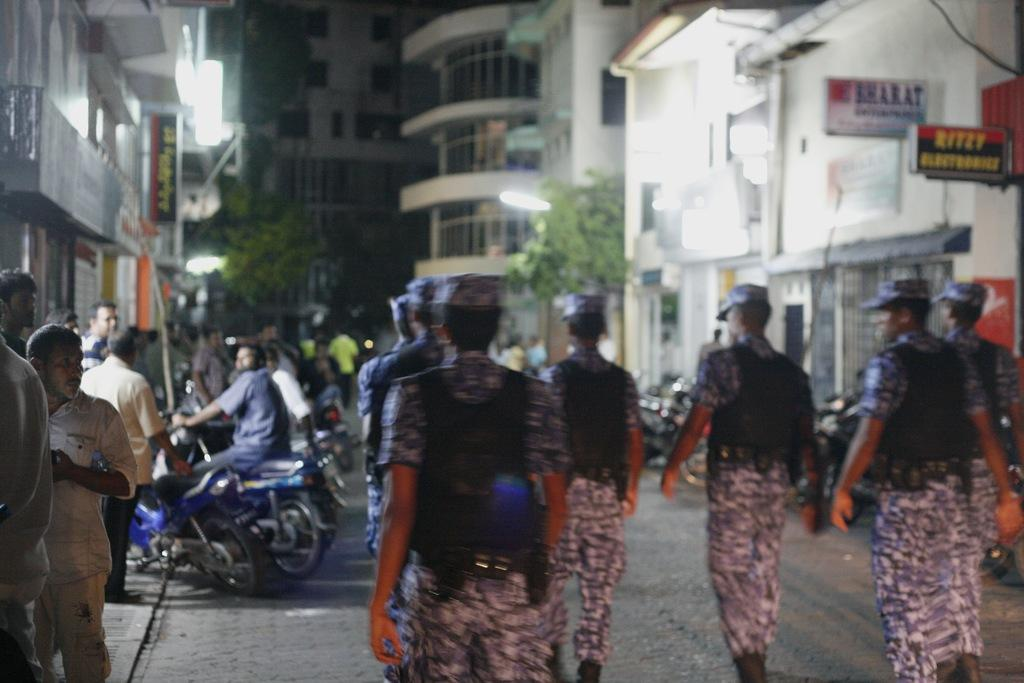What are the people in the image doing? There is a group of people walking in the road. What can be seen in the background of the image? There is a name board, a building, a tree, a light, and a bike in the background. Are there any other people visible in the image? Yes, there is another group of people in the background. What type of zinc is being used to create the name board in the image? There is no mention of zinc or any material used for the name board in the image. How many horses are present in the image? There are no horses present in the image. 